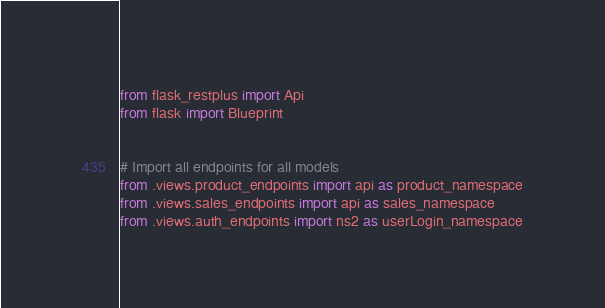Convert code to text. <code><loc_0><loc_0><loc_500><loc_500><_Python_>from flask_restplus import Api
from flask import Blueprint 


# Import all endpoints for all models
from .views.product_endpoints import api as product_namespace
from .views.sales_endpoints import api as sales_namespace
from .views.auth_endpoints import ns2 as userLogin_namespace</code> 